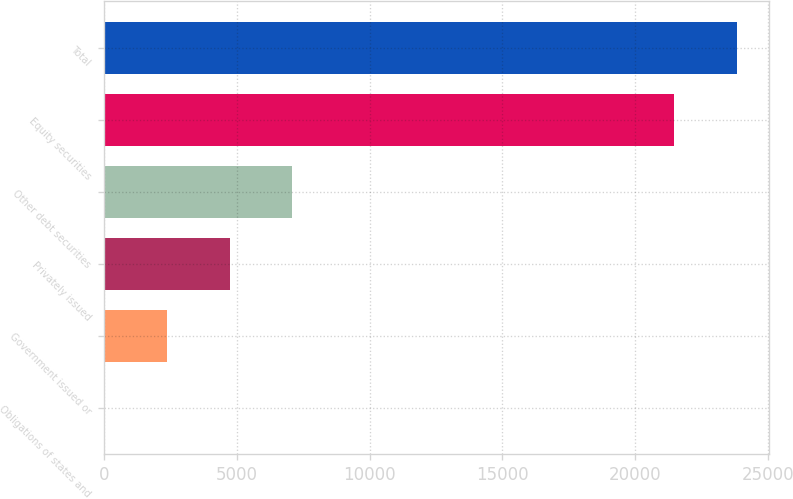Convert chart to OTSL. <chart><loc_0><loc_0><loc_500><loc_500><bar_chart><fcel>Obligations of states and<fcel>Government issued or<fcel>Privately issued<fcel>Other debt securities<fcel>Equity securities<fcel>Total<nl><fcel>6<fcel>2368.8<fcel>4731.6<fcel>7094.4<fcel>21490<fcel>23852.8<nl></chart> 